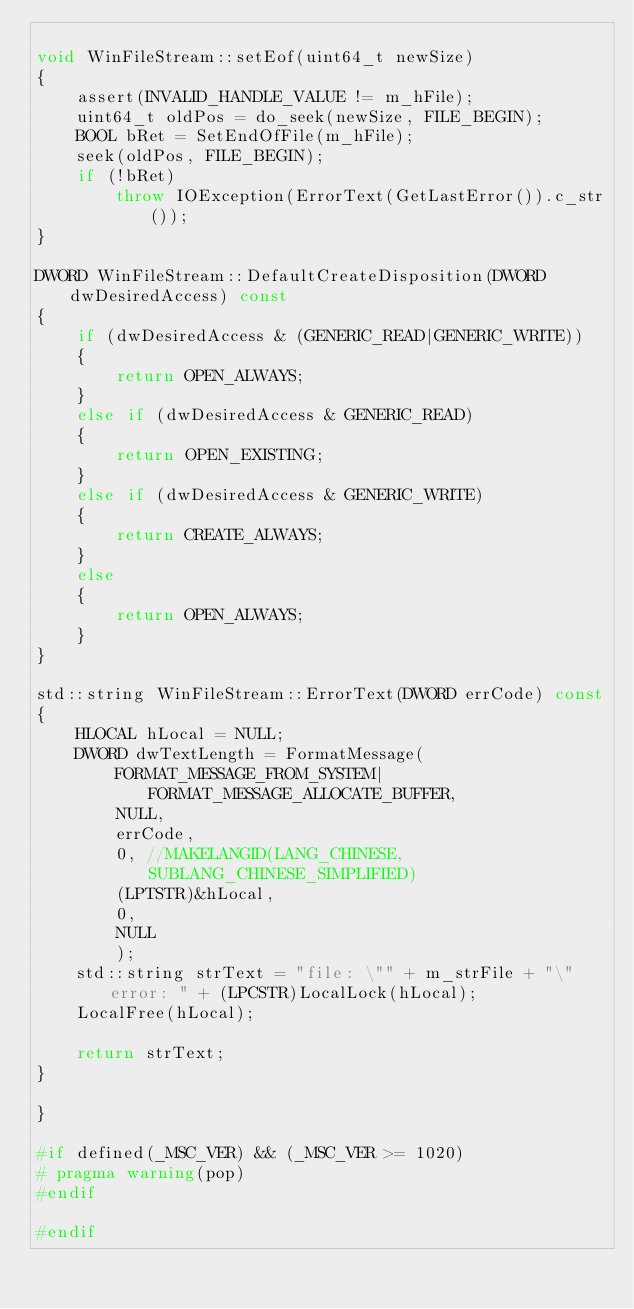<code> <loc_0><loc_0><loc_500><loc_500><_C++_>
void WinFileStream::setEof(uint64_t newSize)
{
	assert(INVALID_HANDLE_VALUE != m_hFile);
	uint64_t oldPos = do_seek(newSize, FILE_BEGIN);
	BOOL bRet = SetEndOfFile(m_hFile);
	seek(oldPos, FILE_BEGIN);
	if (!bRet)
		throw IOException(ErrorText(GetLastError()).c_str());
}

DWORD WinFileStream::DefaultCreateDisposition(DWORD dwDesiredAccess) const
{
	if (dwDesiredAccess & (GENERIC_READ|GENERIC_WRITE))
	{
		return OPEN_ALWAYS;
	}
	else if (dwDesiredAccess & GENERIC_READ)
	{
		return OPEN_EXISTING;
	}
	else if (dwDesiredAccess & GENERIC_WRITE)
	{
		return CREATE_ALWAYS;
	}
	else
	{
		return OPEN_ALWAYS;
	}
}

std::string WinFileStream::ErrorText(DWORD errCode) const
{
	HLOCAL hLocal = NULL;
	DWORD dwTextLength = FormatMessage(
		FORMAT_MESSAGE_FROM_SYSTEM|FORMAT_MESSAGE_ALLOCATE_BUFFER,
		NULL,
		errCode,
		0, //MAKELANGID(LANG_CHINESE, SUBLANG_CHINESE_SIMPLIFIED)
		(LPTSTR)&hLocal,
		0,
		NULL
		);
	std::string strText = "file: \"" + m_strFile + "\" error: " + (LPCSTR)LocalLock(hLocal);
	LocalFree(hLocal);

	return strText;
}

}

#if defined(_MSC_VER) && (_MSC_VER >= 1020)
# pragma warning(pop)
#endif

#endif
</code> 